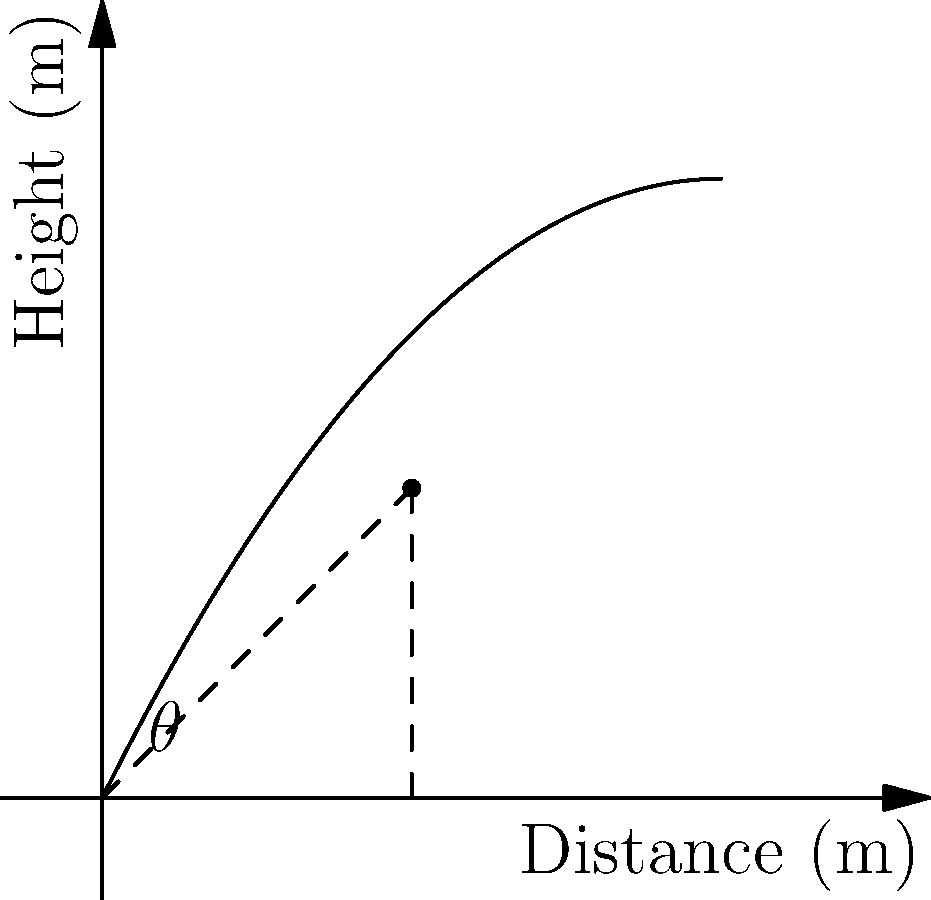During a Huntingdon Town match, a player kicks the ball, and its trajectory is shown in the graph above. If the ball reaches its maximum height of 5 meters at a distance of 5 meters from the kick point, what is the initial angle $\theta$ of the kick? To find the initial angle $\theta$ of the kick, we can use trigonometry:

1. The trajectory forms a right triangle with the ground and the line to the maximum height point.
2. We know the adjacent side (distance) is 5 meters and the opposite side (height) is also 5 meters.
3. The tangent of an angle in a right triangle is the ratio of the opposite side to the adjacent side.
4. So, $\tan(\theta) = \frac{\text{opposite}}{\text{adjacent}} = \frac{5}{5} = 1$
5. To find $\theta$, we need to calculate the inverse tangent (arctangent):
   $\theta = \tan^{-1}(1)$
6. The arctangent of 1 is equal to 45°.

Therefore, the initial angle of the kick is 45°.
Answer: 45° 